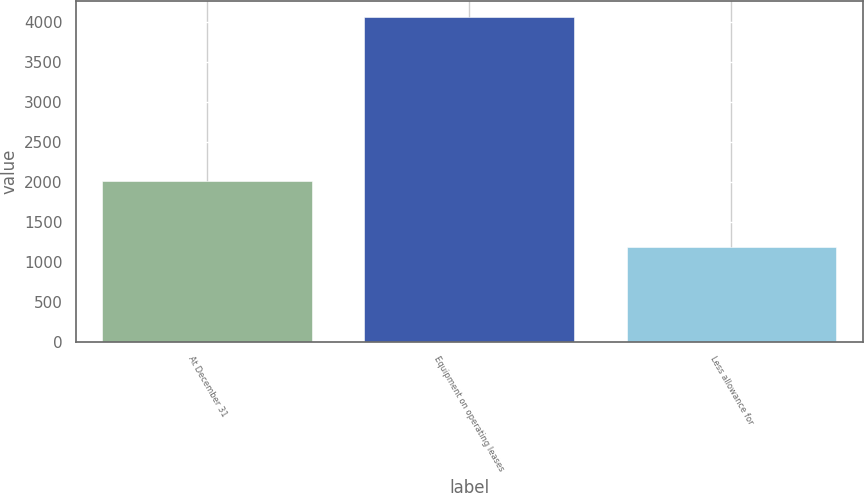Convert chart. <chart><loc_0><loc_0><loc_500><loc_500><bar_chart><fcel>At December 31<fcel>Equipment on operating leases<fcel>Less allowance for<nl><fcel>2017<fcel>4066.3<fcel>1190<nl></chart> 